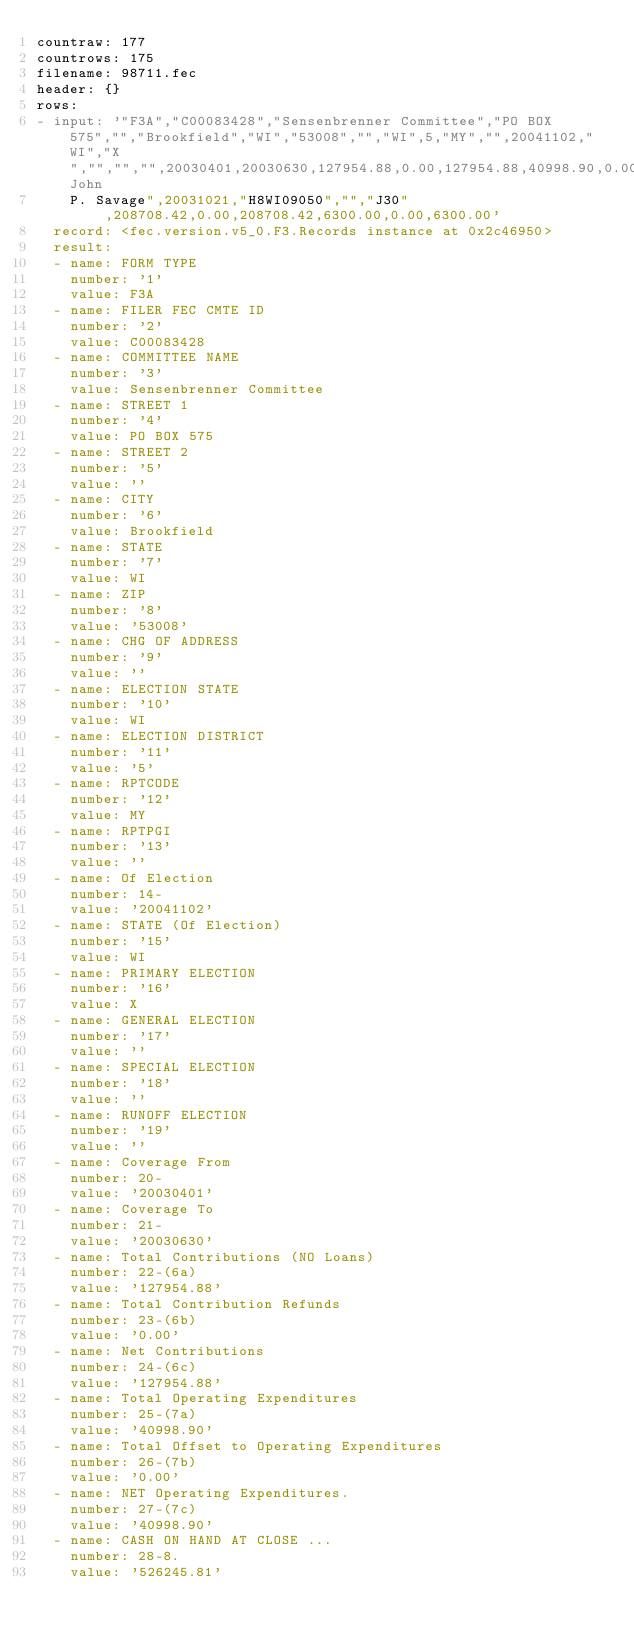Convert code to text. <code><loc_0><loc_0><loc_500><loc_500><_YAML_>countraw: 177
countrows: 175
filename: 98711.fec
header: {}
rows:
- input: '"F3A","C00083428","Sensenbrenner Committee","PO BOX 575","","Brookfield","WI","53008","","WI",5,"MY","",20041102,"WI","X","","","",20030401,20030630,127954.88,0.00,127954.88,40998.90,0.00,40998.90,526245.81,0.00,0.00,17690.00,22567.00,40257.00,0.00,87697.88,0.00,127954.88,0.00,0.00,0.00,0.00,0.00,645.66,128600.54,40998.90,0.00,0.00,0.00,0.00,0.00,0.00,0.00,0.00,0.00,40998.90,438644.17,128600.54,567244.71,40998.90,526245.81,213449.88,0.00,213449.88,102837.64,0.00,102837.64,41840.00,24422.00,66262.00,500.00,146687.88,0.00,213449.88,0.00,0.00,0.00,0.00,0.00,1558.54,215008.42,102837.64,0.00,0.00,0.00,0.00,0.00,0.00,0.00,0.00,0.00,102837.64,"John
    P. Savage",20031021,"H8WI09050","","J30",208708.42,0.00,208708.42,6300.00,0.00,6300.00'
  record: <fec.version.v5_0.F3.Records instance at 0x2c46950>
  result:
  - name: FORM TYPE
    number: '1'
    value: F3A
  - name: FILER FEC CMTE ID
    number: '2'
    value: C00083428
  - name: COMMITTEE NAME
    number: '3'
    value: Sensenbrenner Committee
  - name: STREET 1
    number: '4'
    value: PO BOX 575
  - name: STREET 2
    number: '5'
    value: ''
  - name: CITY
    number: '6'
    value: Brookfield
  - name: STATE
    number: '7'
    value: WI
  - name: ZIP
    number: '8'
    value: '53008'
  - name: CHG OF ADDRESS
    number: '9'
    value: ''
  - name: ELECTION STATE
    number: '10'
    value: WI
  - name: ELECTION DISTRICT
    number: '11'
    value: '5'
  - name: RPTCODE
    number: '12'
    value: MY
  - name: RPTPGI
    number: '13'
    value: ''
  - name: Of Election
    number: 14-
    value: '20041102'
  - name: STATE (Of Election)
    number: '15'
    value: WI
  - name: PRIMARY ELECTION
    number: '16'
    value: X
  - name: GENERAL ELECTION
    number: '17'
    value: ''
  - name: SPECIAL ELECTION
    number: '18'
    value: ''
  - name: RUNOFF ELECTION
    number: '19'
    value: ''
  - name: Coverage From
    number: 20-
    value: '20030401'
  - name: Coverage To
    number: 21-
    value: '20030630'
  - name: Total Contributions (NO Loans)
    number: 22-(6a)
    value: '127954.88'
  - name: Total Contribution Refunds
    number: 23-(6b)
    value: '0.00'
  - name: Net Contributions
    number: 24-(6c)
    value: '127954.88'
  - name: Total Operating Expenditures
    number: 25-(7a)
    value: '40998.90'
  - name: Total Offset to Operating Expenditures
    number: 26-(7b)
    value: '0.00'
  - name: NET Operating Expenditures.
    number: 27-(7c)
    value: '40998.90'
  - name: CASH ON HAND AT CLOSE ...
    number: 28-8.
    value: '526245.81'</code> 